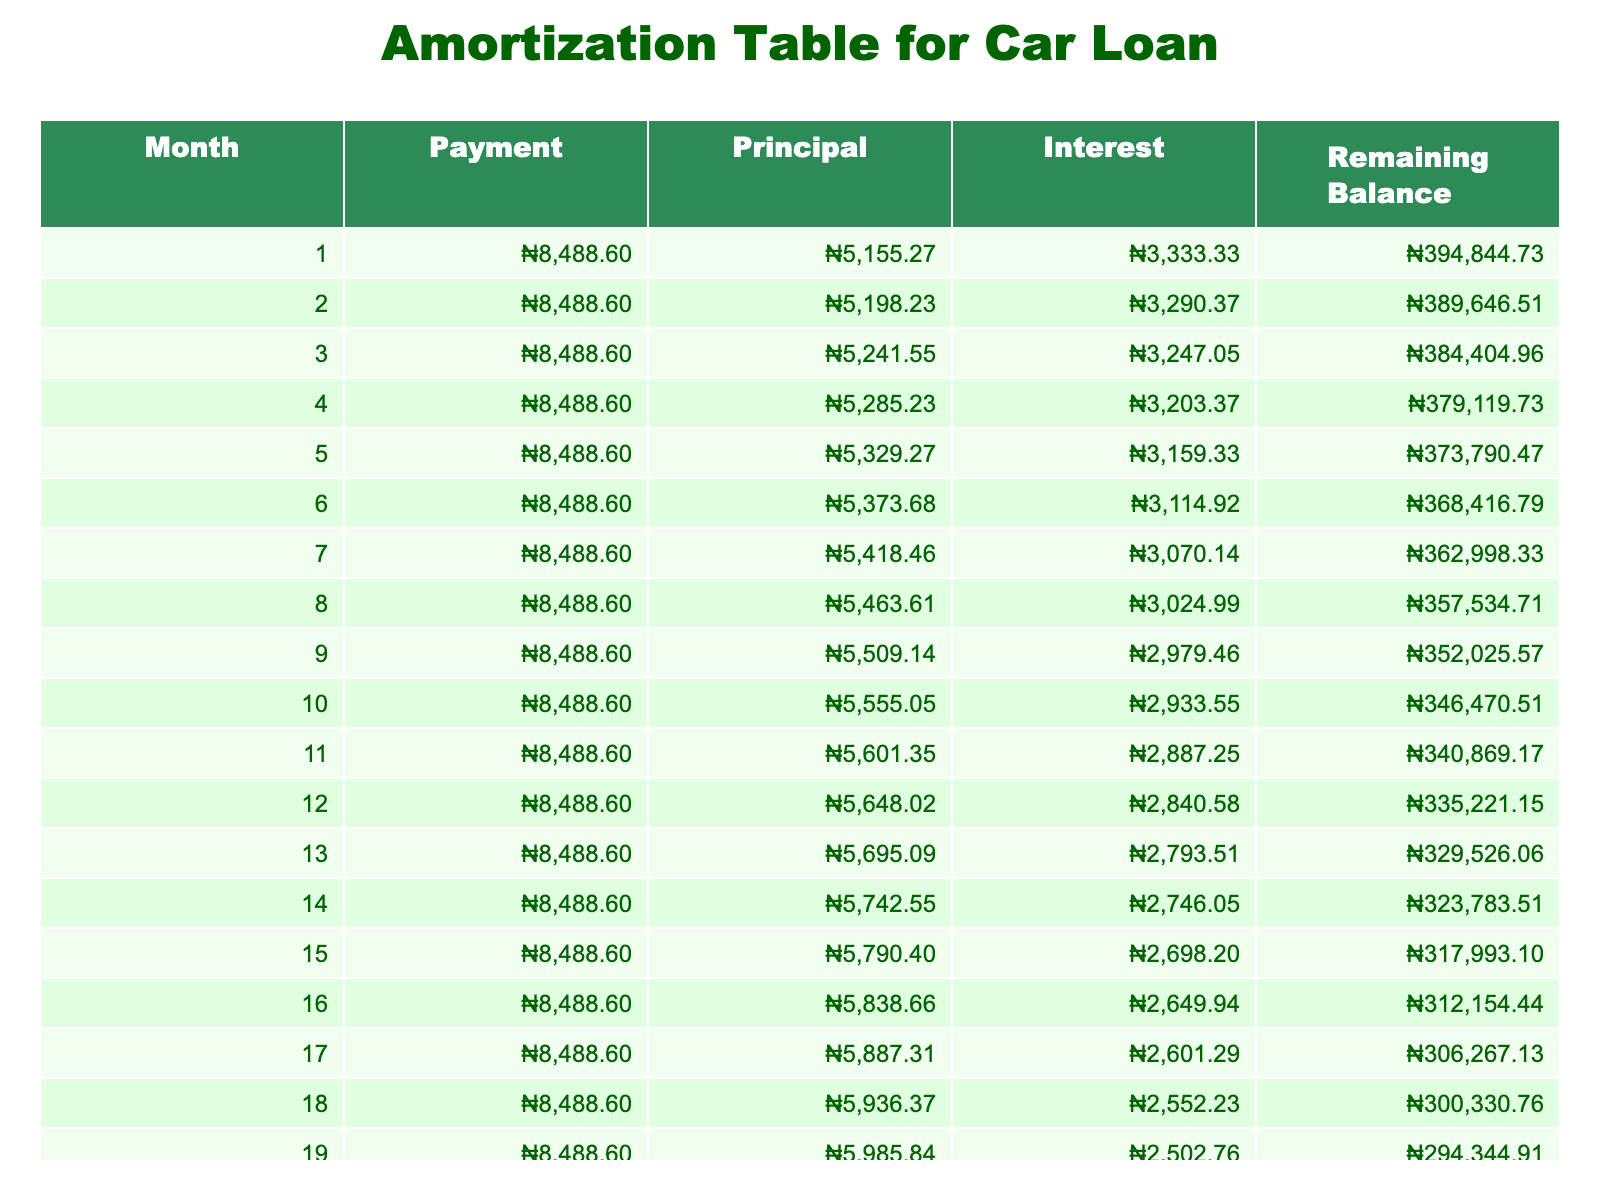What is the total loan amount? The loan amount is provided clearly in the table under the 'Loan Amount' column. It states ₦400,000.
Answer: ₦400,000 How much is the monthly payment? The table shows the 'Monthly Payment' for the loan. It indicates that the monthly payment is ₦8,488.60.
Answer: ₦8,488.60 What will be the total amount paid over the loan term? The 'Total Payment' in the table reveals the overall amount paid after the loan term. According to the table, the total payment is ₦509,156.
Answer: ₦509,156 Is the total interest paid more than ₦100,000? The 'Total Interest' column shows an interest amount of ₦109,156. This means it is indeed greater than ₦100,000.
Answer: Yes What is the remaining balance after the first month? To find the remaining balance after the first month, we subtract the principal payment from the original loan amount. The principal payment can be calculated as the monthly payment minus the interest payment for that month. After performing the calculations, the remaining balance is ₦391,511.40.
Answer: ₦391,511.40 What is the ratio of the total interest paid to the total payment made? To find this ratio, divide the 'Total Interest' by the 'Total Payment': ₦109,156 / ₦509,156 = 0.214 or approximately 21.4%.
Answer: 21.4% How much of the first payment goes towards the principal? The first month's interest payment can be determined first. It's calculated using the loan amount and monthly interest rate. The first principal payment is then the monthly payment minus the first month’s interest. The answer is approximately ₦5,140.30.
Answer: ₦5,140.30 At the end of the loan term, is the remaining balance equal to zero? By the end of the specified loan term, the balance must be fully paid off, which indicates that the remaining balance is indeed zero.
Answer: Yes What is the total interest paid by the end of the loan term? The 'Total Interest' column indicates the total interest paid by the loan's term, which is ₦109,156.
Answer: ₦109,156 